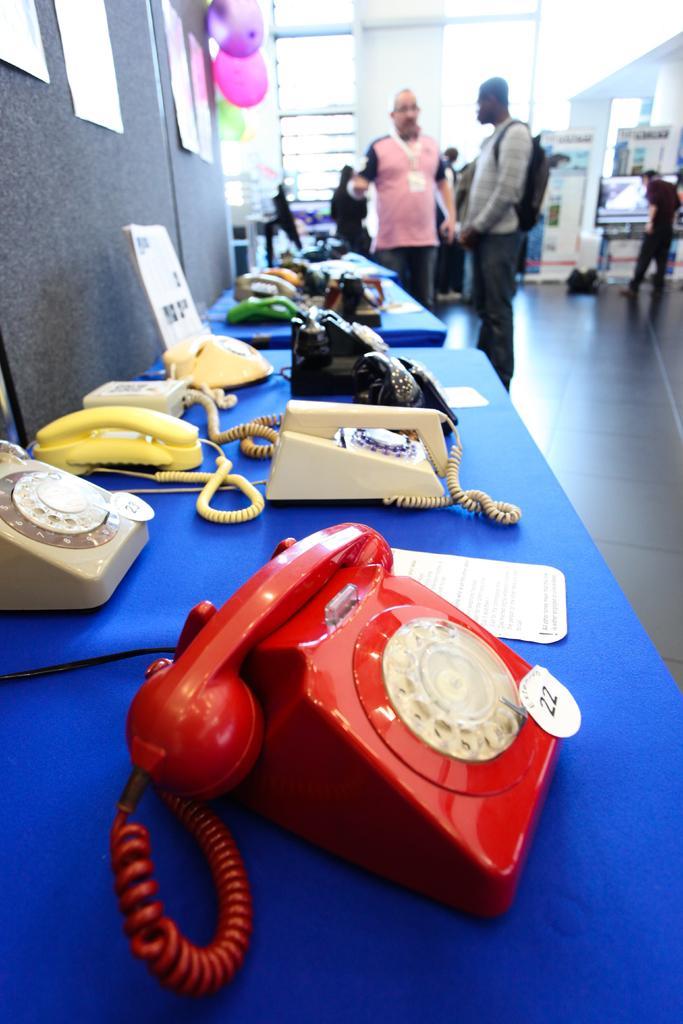How would you summarize this image in a sentence or two? In this picture we can see few telephones and papers on the table, in the background we can find few people, and also we can see few balloons on the wall. 